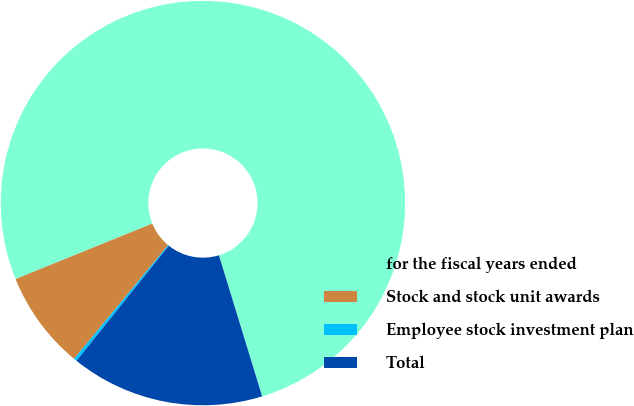Convert chart to OTSL. <chart><loc_0><loc_0><loc_500><loc_500><pie_chart><fcel>for the fiscal years ended<fcel>Stock and stock unit awards<fcel>Employee stock investment plan<fcel>Total<nl><fcel>76.4%<fcel>7.87%<fcel>0.25%<fcel>15.48%<nl></chart> 